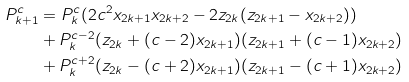<formula> <loc_0><loc_0><loc_500><loc_500>P _ { k + 1 } ^ { c } & = P _ { k } ^ { c } ( 2 c ^ { 2 } x _ { 2 k + 1 } x _ { 2 k + 2 } - 2 z _ { 2 k } ( z _ { 2 k + 1 } - x _ { 2 k + 2 } ) ) \\ & + P _ { k } ^ { c - 2 } ( z _ { 2 k } + ( c - 2 ) x _ { 2 k + 1 } ) ( z _ { 2 k + 1 } + ( c - 1 ) x _ { 2 k + 2 } ) \\ & + P _ { k } ^ { c + 2 } ( z _ { 2 k } - ( c + 2 ) x _ { 2 k + 1 } ) ( z _ { 2 k + 1 } - ( c + 1 ) x _ { 2 k + 2 } )</formula> 